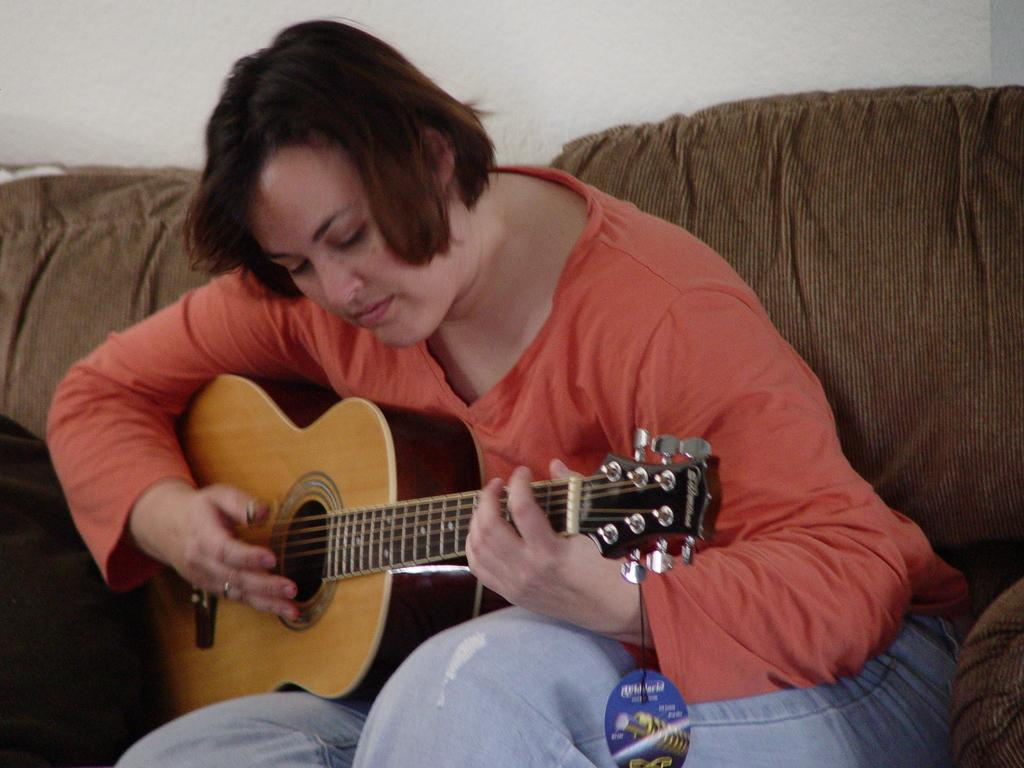What is the person in the image doing? The person is sitting on a couch in the image. What object is the person holding? The person is holding a guitar. What can be seen in the background of the image? There is a wall in the background of the image. How many people are in the crowd surrounding the person playing the guitar in the image? There is no crowd present in the image; it only features a person sitting on a couch holding a guitar. What type of garden can be seen in the image? There is no garden present in the image; it only features a person sitting on a couch holding a guitar and a wall in the background. 